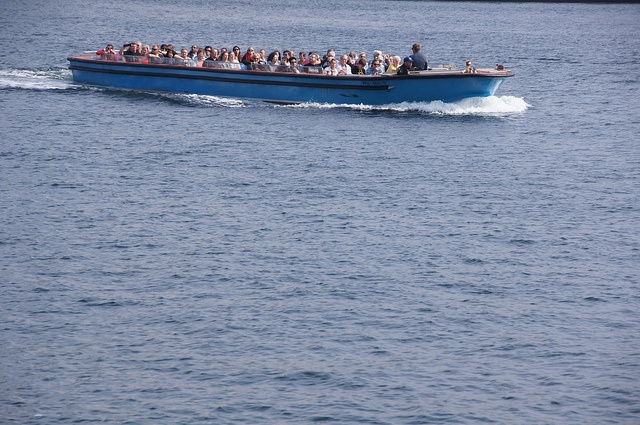Describe the objects in this image and their specific colors. I can see boat in gray, darkblue, black, navy, and blue tones, people in gray, darkgray, and black tones, people in gray, black, and navy tones, people in gray and black tones, and people in gray, brown, darkgray, and black tones in this image. 